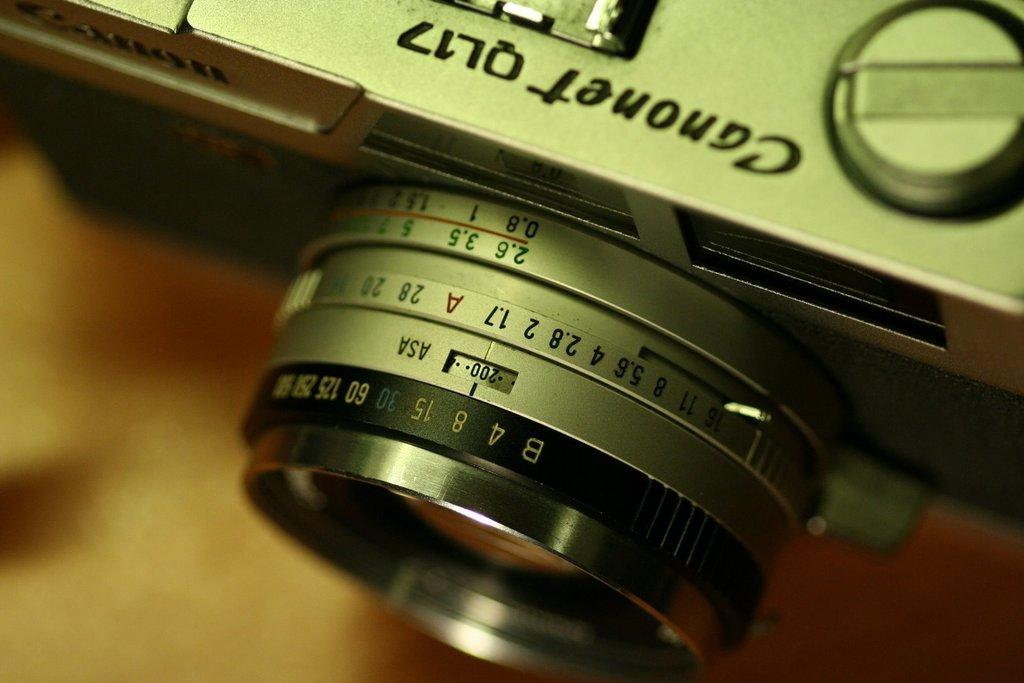What is the main subject of the image? The main subject of the image is the lens of a camera. What type of steel is used to manufacture the camera lens in the image? There is no information about the type of steel used in the camera lens, as the fact provided only mentions the lens being visible in the image. 